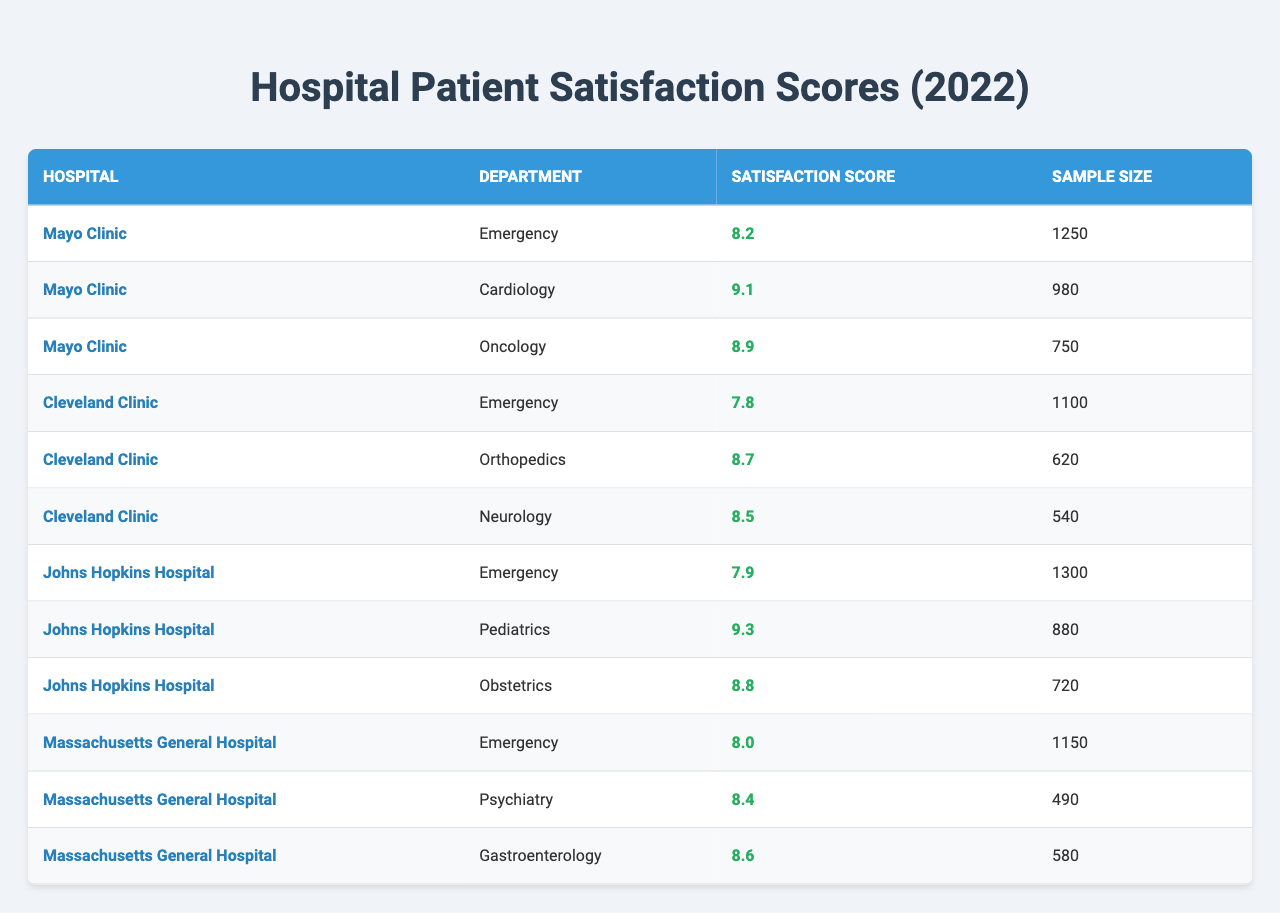What is the satisfaction score for the Cardiology department at Mayo Clinic? The table lists the satisfaction score for the Cardiology department under Mayo Clinic as 9.1.
Answer: 9.1 Which hospital has the highest satisfaction score in the Emergency department? By comparing the satisfaction scores for the Emergency department across all hospitals, it can be seen that Mayo Clinic has the highest score at 8.2.
Answer: Mayo Clinic How many patients were surveyed in the Pediatrics department at Johns Hopkins Hospital? According to the table, the sample size for the Pediatrics department at Johns Hopkins Hospital is 880.
Answer: 880 What is the average satisfaction score across all departments at Cleveland Clinic? The average can be calculated by adding the satisfaction scores for all departments at Cleveland Clinic (7.8 + 8.7 + 8.5) = 25, and dividing by the number of departments (3), resulting in an average of 25/3 = 8.33.
Answer: 8.33 Did Massachusetts General Hospital achieve a satisfaction score of 9 or higher in any of its departments? By reviewing the scores in the table, none of the departments at Massachusetts General Hospital have a satisfaction score of 9 or higher.
Answer: No Which department at Johns Hopkins Hospital has the highest satisfaction score? The table shows the satisfaction scores for Johns Hopkins Hospital: Emergency (7.9), Pediatrics (9.3), and Obstetrics (8.8). The highest score is in the Pediatrics department with 9.3.
Answer: Pediatrics What is the combined sample size for the Emergency departments across all hospitals? The sample sizes for the Emergency departments are: Mayo Clinic (1250), Cleveland Clinic (1100), and Johns Hopkins Hospital (1300). Adding these gives 1250 + 1100 + 1300 = 3650.
Answer: 3650 Which department has the lowest satisfaction score overall? The overall lowest score can be determined by comparing all satisfaction scores listed: the Emergency department at Cleveland Clinic has the lowest score of 7.8.
Answer: Emergency at Cleveland Clinic What is the difference in the satisfaction score between Cardiology at Mayo Clinic and Orthopedics at Cleveland Clinic? The satisfaction score for Cardiology at Mayo Clinic is 9.1 and for Orthopedics at Cleveland Clinic is 8.7. The difference is 9.1 - 8.7 = 0.4.
Answer: 0.4 Are there more than 500 patients surveyed in the Psychiatry department at Massachusetts General Hospital? The sample size for the Psychiatry department is 490, which is not more than 500.
Answer: No 